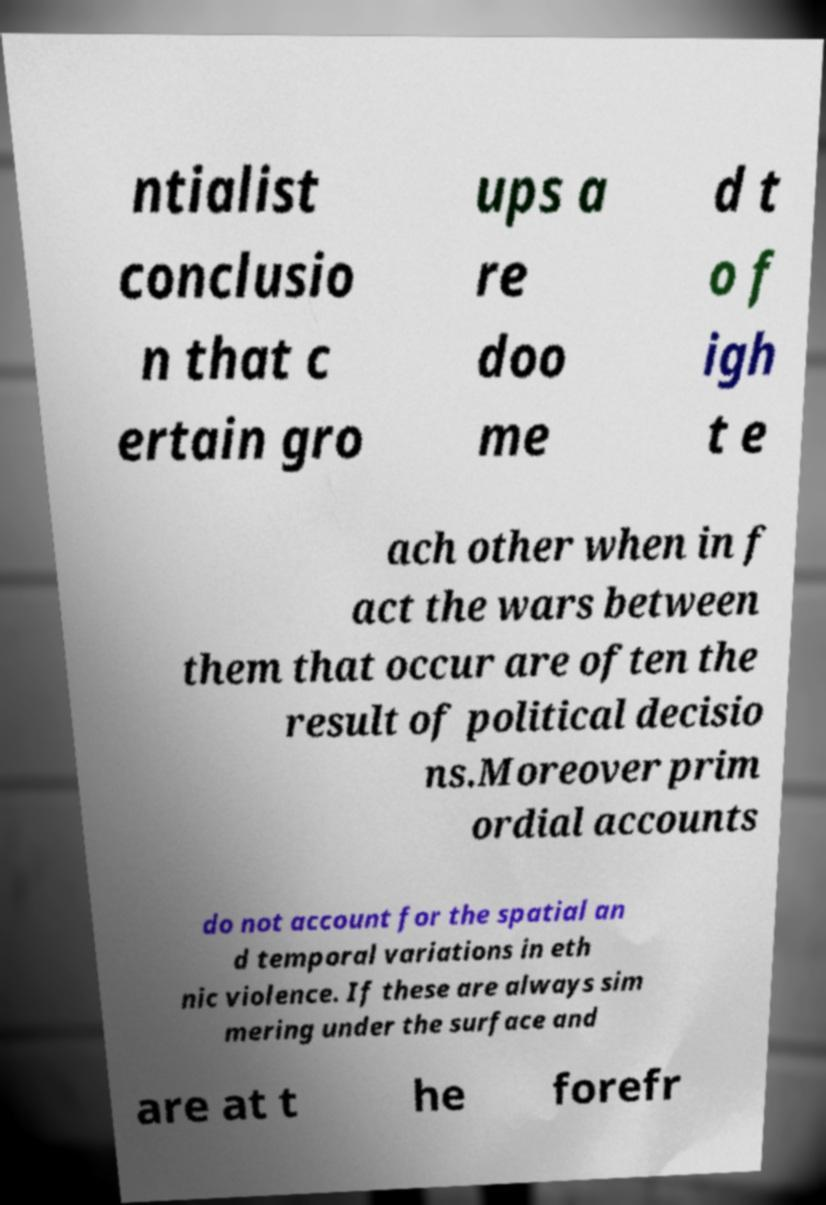Can you accurately transcribe the text from the provided image for me? ntialist conclusio n that c ertain gro ups a re doo me d t o f igh t e ach other when in f act the wars between them that occur are often the result of political decisio ns.Moreover prim ordial accounts do not account for the spatial an d temporal variations in eth nic violence. If these are always sim mering under the surface and are at t he forefr 